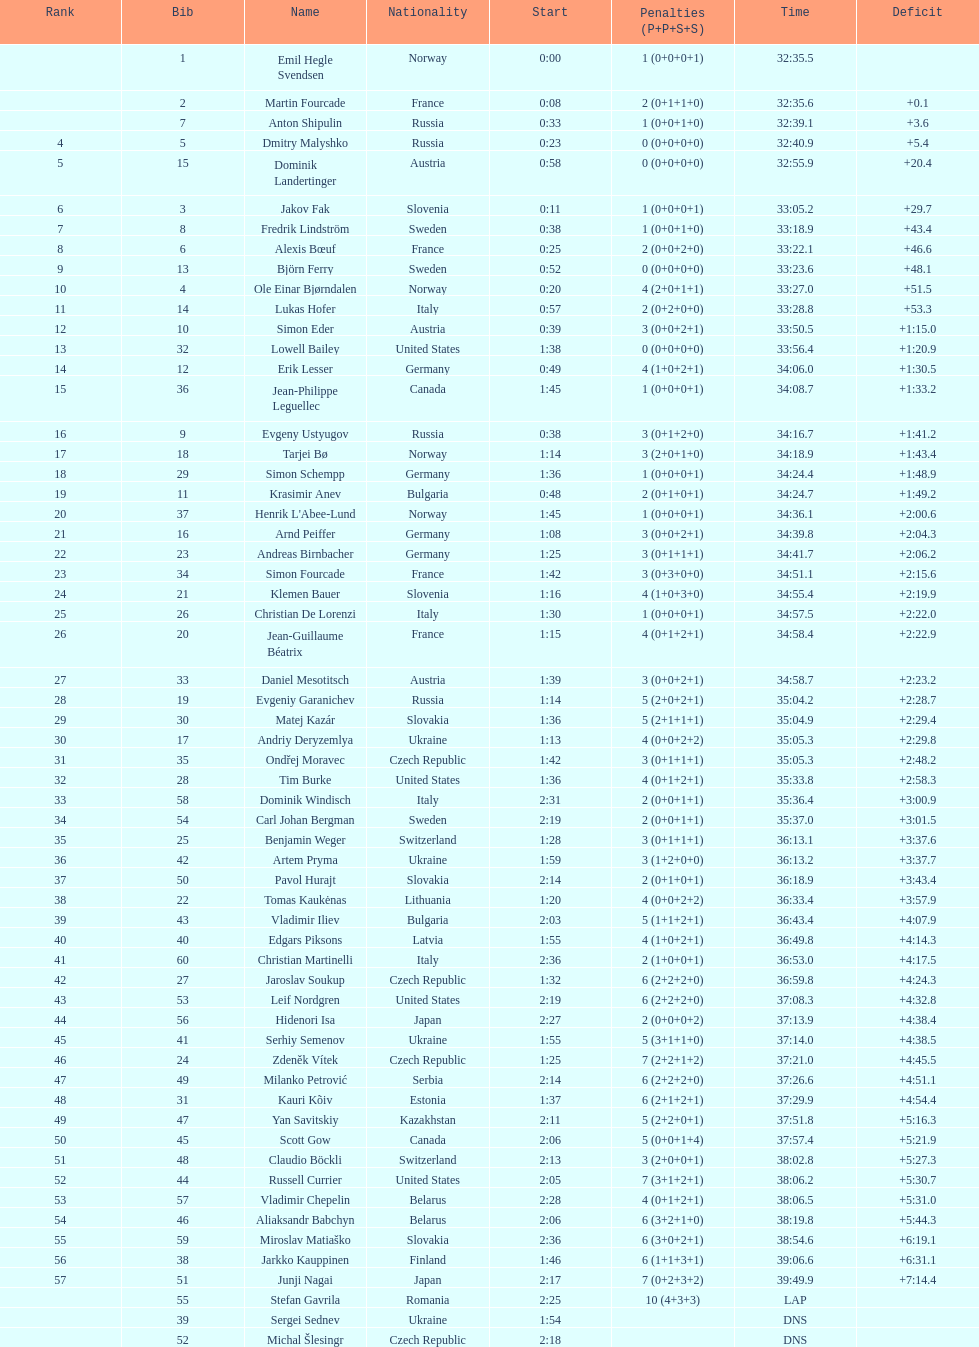Other than burke, name an athlete from the us. Leif Nordgren. 